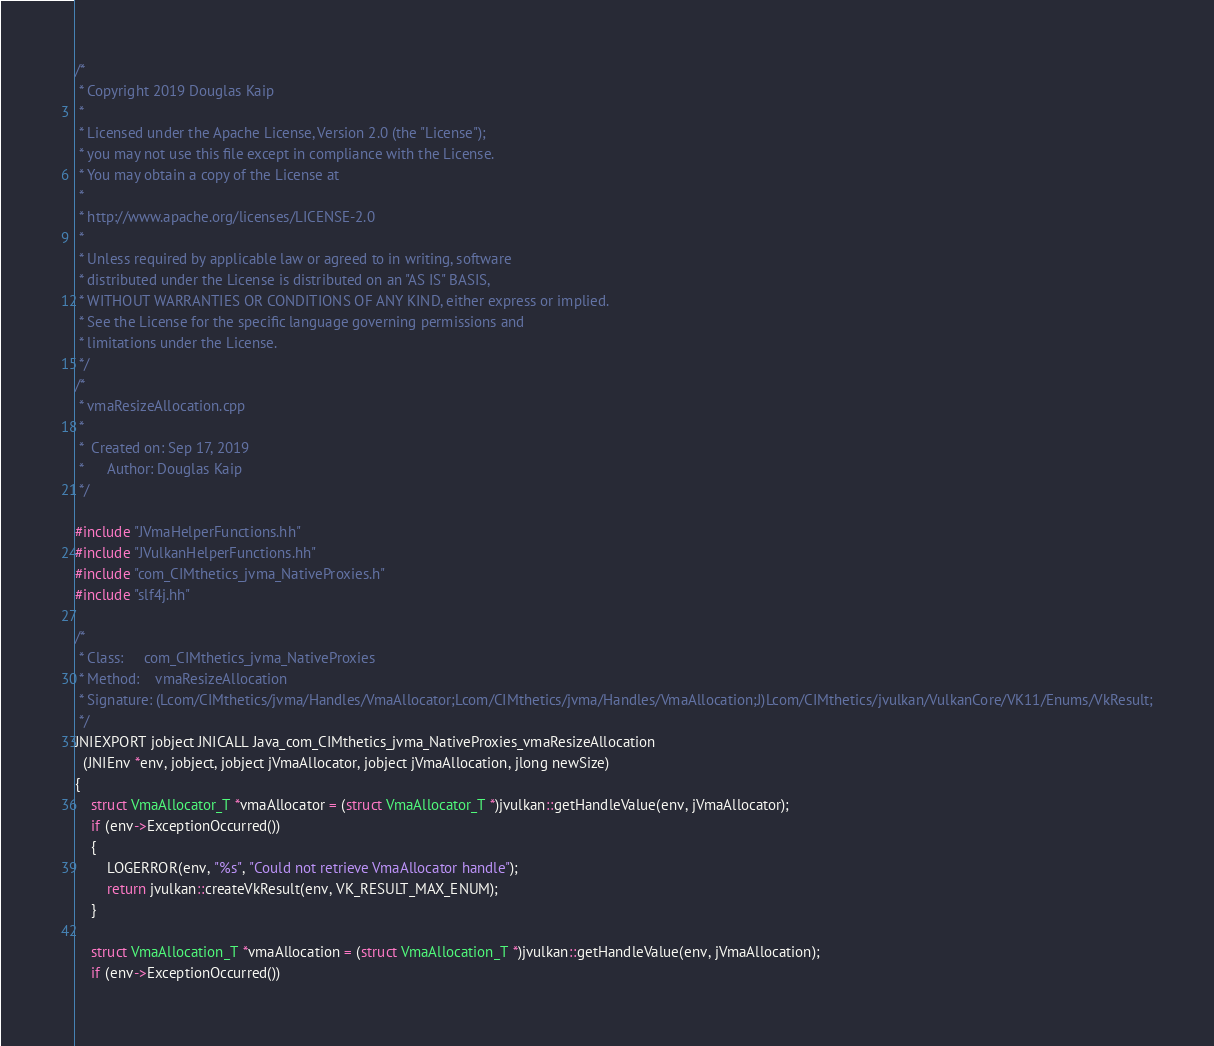<code> <loc_0><loc_0><loc_500><loc_500><_C++_>/*
 * Copyright 2019 Douglas Kaip
 *
 * Licensed under the Apache License, Version 2.0 (the "License");
 * you may not use this file except in compliance with the License.
 * You may obtain a copy of the License at
 *
 * http://www.apache.org/licenses/LICENSE-2.0
 *
 * Unless required by applicable law or agreed to in writing, software
 * distributed under the License is distributed on an "AS IS" BASIS,
 * WITHOUT WARRANTIES OR CONDITIONS OF ANY KIND, either express or implied.
 * See the License for the specific language governing permissions and
 * limitations under the License.
 */
/*
 * vmaResizeAllocation.cpp
 *
 *  Created on: Sep 17, 2019
 *      Author: Douglas Kaip
 */

#include "JVmaHelperFunctions.hh"
#include "JVulkanHelperFunctions.hh"
#include "com_CIMthetics_jvma_NativeProxies.h"
#include "slf4j.hh"

/*
 * Class:     com_CIMthetics_jvma_NativeProxies
 * Method:    vmaResizeAllocation
 * Signature: (Lcom/CIMthetics/jvma/Handles/VmaAllocator;Lcom/CIMthetics/jvma/Handles/VmaAllocation;J)Lcom/CIMthetics/jvulkan/VulkanCore/VK11/Enums/VkResult;
 */
JNIEXPORT jobject JNICALL Java_com_CIMthetics_jvma_NativeProxies_vmaResizeAllocation
  (JNIEnv *env, jobject, jobject jVmaAllocator, jobject jVmaAllocation, jlong newSize)
{
    struct VmaAllocator_T *vmaAllocator = (struct VmaAllocator_T *)jvulkan::getHandleValue(env, jVmaAllocator);
    if (env->ExceptionOccurred())
    {
        LOGERROR(env, "%s", "Could not retrieve VmaAllocator handle");
        return jvulkan::createVkResult(env, VK_RESULT_MAX_ENUM);
    }

    struct VmaAllocation_T *vmaAllocation = (struct VmaAllocation_T *)jvulkan::getHandleValue(env, jVmaAllocation);
    if (env->ExceptionOccurred())</code> 